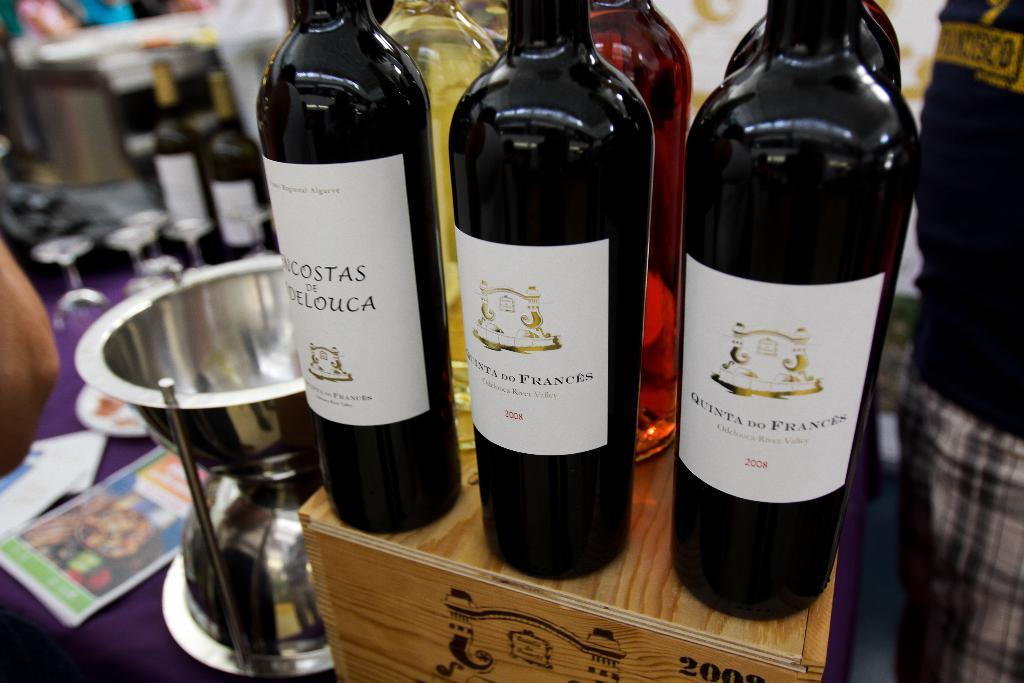<image>
Create a compact narrative representing the image presented. Two bottles of Quinta do Frances from 2008 sit on a crate with some other wine bottles. 